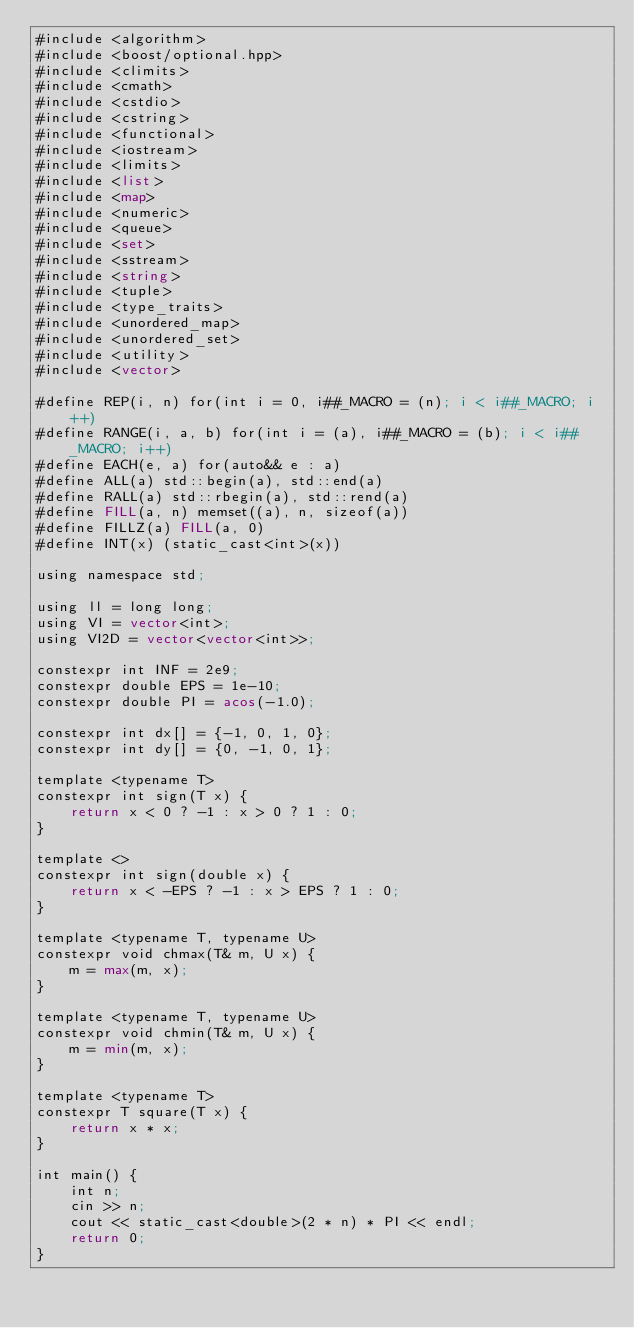Convert code to text. <code><loc_0><loc_0><loc_500><loc_500><_Lisp_>#include <algorithm>
#include <boost/optional.hpp>
#include <climits>
#include <cmath>
#include <cstdio>
#include <cstring>
#include <functional>
#include <iostream>
#include <limits>
#include <list>
#include <map>
#include <numeric>
#include <queue>
#include <set>
#include <sstream>
#include <string>
#include <tuple>
#include <type_traits>
#include <unordered_map>
#include <unordered_set>
#include <utility>
#include <vector>

#define REP(i, n) for(int i = 0, i##_MACRO = (n); i < i##_MACRO; i++)
#define RANGE(i, a, b) for(int i = (a), i##_MACRO = (b); i < i##_MACRO; i++)
#define EACH(e, a) for(auto&& e : a)
#define ALL(a) std::begin(a), std::end(a)
#define RALL(a) std::rbegin(a), std::rend(a)
#define FILL(a, n) memset((a), n, sizeof(a))
#define FILLZ(a) FILL(a, 0)
#define INT(x) (static_cast<int>(x))

using namespace std;

using ll = long long;
using VI = vector<int>;
using VI2D = vector<vector<int>>;

constexpr int INF = 2e9;
constexpr double EPS = 1e-10;
constexpr double PI = acos(-1.0);

constexpr int dx[] = {-1, 0, 1, 0};
constexpr int dy[] = {0, -1, 0, 1};

template <typename T>
constexpr int sign(T x) {
	return x < 0 ? -1 : x > 0 ? 1 : 0;
}

template <>
constexpr int sign(double x) {
	return x < -EPS ? -1 : x > EPS ? 1 : 0;
}

template <typename T, typename U>
constexpr void chmax(T& m, U x) {
	m = max(m, x);
}

template <typename T, typename U>
constexpr void chmin(T& m, U x) {
	m = min(m, x);
}

template <typename T>
constexpr T square(T x) {
	return x * x;
}

int main() {
	int n;
	cin >> n;
	cout << static_cast<double>(2 * n) * PI << endl;
	return 0;
}
</code> 